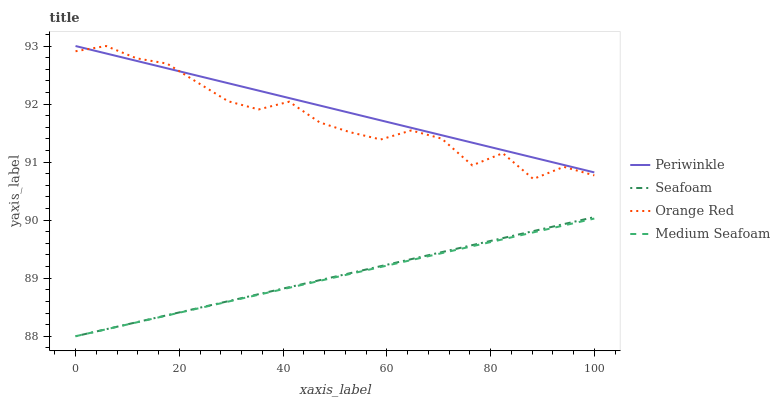Does Medium Seafoam have the minimum area under the curve?
Answer yes or no. Yes. Does Periwinkle have the maximum area under the curve?
Answer yes or no. Yes. Does Seafoam have the minimum area under the curve?
Answer yes or no. No. Does Seafoam have the maximum area under the curve?
Answer yes or no. No. Is Seafoam the smoothest?
Answer yes or no. Yes. Is Orange Red the roughest?
Answer yes or no. Yes. Is Periwinkle the smoothest?
Answer yes or no. No. Is Periwinkle the roughest?
Answer yes or no. No. Does Medium Seafoam have the lowest value?
Answer yes or no. Yes. Does Periwinkle have the lowest value?
Answer yes or no. No. Does Orange Red have the highest value?
Answer yes or no. Yes. Does Seafoam have the highest value?
Answer yes or no. No. Is Seafoam less than Periwinkle?
Answer yes or no. Yes. Is Orange Red greater than Seafoam?
Answer yes or no. Yes. Does Medium Seafoam intersect Seafoam?
Answer yes or no. Yes. Is Medium Seafoam less than Seafoam?
Answer yes or no. No. Is Medium Seafoam greater than Seafoam?
Answer yes or no. No. Does Seafoam intersect Periwinkle?
Answer yes or no. No. 